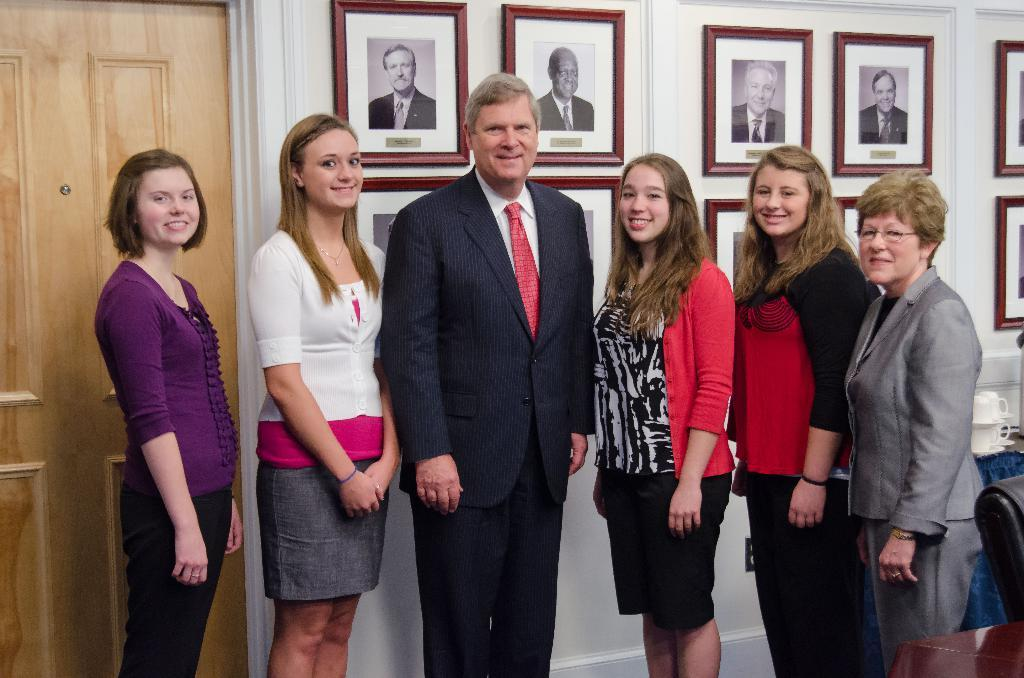What is happening in the image? There is a group of people standing in the image. Where is the door located in the image? The door is on the left side of the image. What can be seen on the wall in the background of the image? There are photo frames on the wall in the background of the image. What type of flame can be seen coming from the coil in the image? There is no flame or coil present in the image. How much payment is required to enter the room through the door in the image? There is no indication of payment or a room in the image; it simply shows a group of people standing and a door on the left side. 